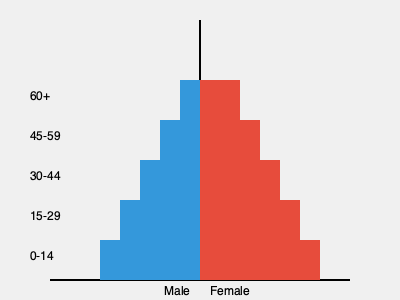As an investor interested in scaling an online learning platform, you're analyzing the population pyramid of a potential target market. Based on the pyramid, which age group would likely be the most profitable to focus on for user acquisition and why? To determine the most profitable age group for user acquisition, we need to consider several factors:

1. Size of the population: Larger segments represent more potential users.
2. Digital literacy: Younger generations tend to be more tech-savvy.
3. Purchasing power: Middle-aged groups often have higher disposable income.
4. Long-term value: Younger users may provide longer lifetime value.

Analyzing the pyramid:

1. The 0-14 age group is large but may not have purchasing power or decision-making ability for online courses.
2. The 15-29 age group is the largest, tech-savvy, and likely to be in education or early career stages.
3. The 30-44 age group is sizeable and likely to have career advancement needs and disposable income.
4. The 45-59 and 60+ age groups are smaller and may be less inclined to use online learning platforms.

Considering these factors, the 15-29 age group appears to be the most profitable to focus on because:

1. It's the largest segment, offering the biggest pool of potential users.
2. This age group is likely to be tech-savvy and comfortable with online learning.
3. They are at a stage where education and skill development are crucial for career growth.
4. They have a long potential lifetime value as users of the platform.
5. While they may have less disposable income than older groups, they are more likely to invest in education and skills training.

Additionally, focusing on this group could lead to organic growth through peer recommendations and create a strong user base that could continue using the platform as they advance in their careers.
Answer: 15-29 age group 